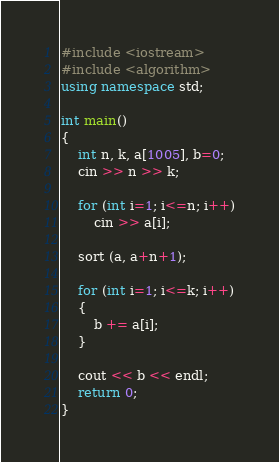Convert code to text. <code><loc_0><loc_0><loc_500><loc_500><_C++_>#include <iostream>
#include <algorithm>
using namespace std;

int main()
{
	int n, k, a[1005], b=0;
	cin >> n >> k;
	
	for (int i=1; i<=n; i++)
		cin >> a[i];
	
	sort (a, a+n+1);
	
	for (int i=1; i<=k; i++)
	{
		b += a[i];
	}
	
	cout << b << endl;
	return 0;
}</code> 